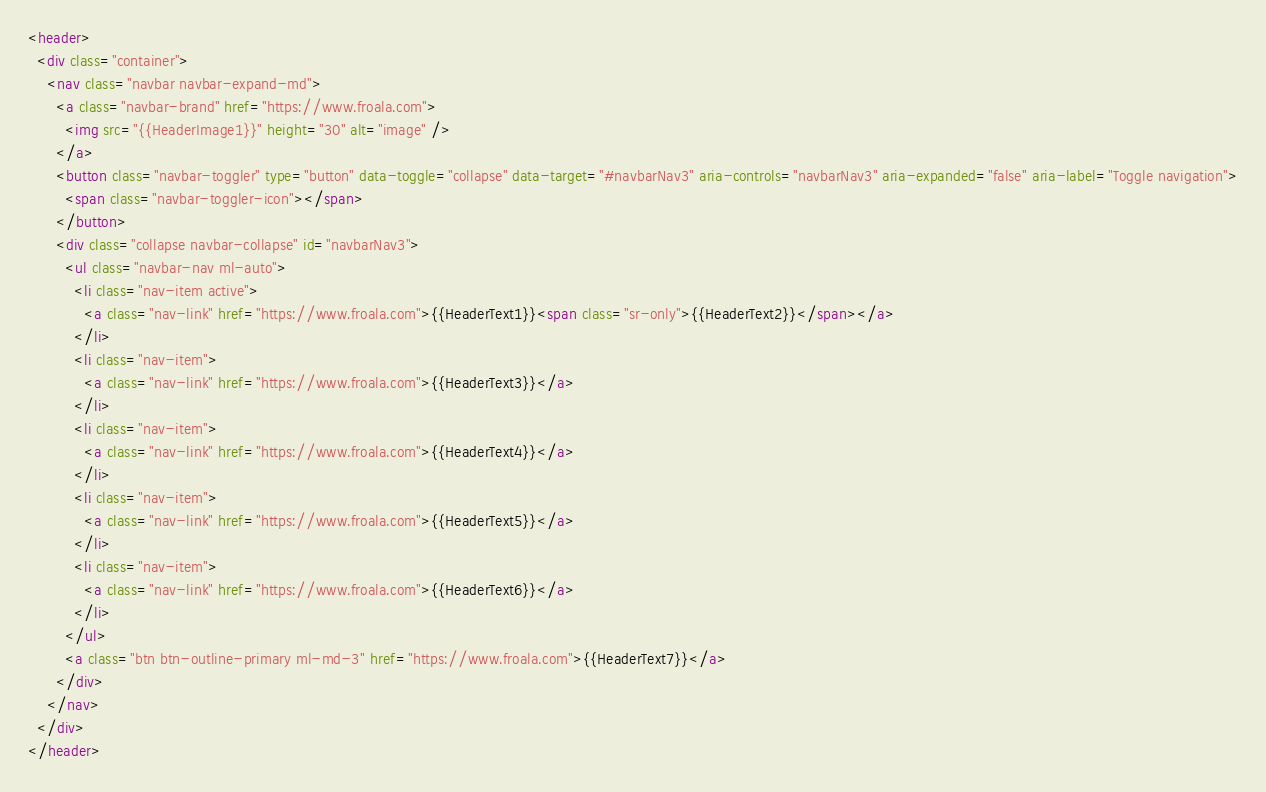<code> <loc_0><loc_0><loc_500><loc_500><_HTML_><header>
  <div class="container">
    <nav class="navbar navbar-expand-md">
      <a class="navbar-brand" href="https://www.froala.com">
        <img src="{{HeaderImage1}}" height="30" alt="image" />
      </a>
      <button class="navbar-toggler" type="button" data-toggle="collapse" data-target="#navbarNav3" aria-controls="navbarNav3" aria-expanded="false" aria-label="Toggle navigation">
        <span class="navbar-toggler-icon"></span>
      </button>
      <div class="collapse navbar-collapse" id="navbarNav3">
        <ul class="navbar-nav ml-auto">
          <li class="nav-item active">
            <a class="nav-link" href="https://www.froala.com">{{HeaderText1}}<span class="sr-only">{{HeaderText2}}</span></a>
          </li>
          <li class="nav-item">
            <a class="nav-link" href="https://www.froala.com">{{HeaderText3}}</a>
          </li>
          <li class="nav-item">
            <a class="nav-link" href="https://www.froala.com">{{HeaderText4}}</a>
          </li>
          <li class="nav-item">
            <a class="nav-link" href="https://www.froala.com">{{HeaderText5}}</a>
          </li>
          <li class="nav-item">
            <a class="nav-link" href="https://www.froala.com">{{HeaderText6}}</a>
          </li>
        </ul>
        <a class="btn btn-outline-primary ml-md-3" href="https://www.froala.com">{{HeaderText7}}</a>
      </div>
    </nav>
  </div>
</header></code> 